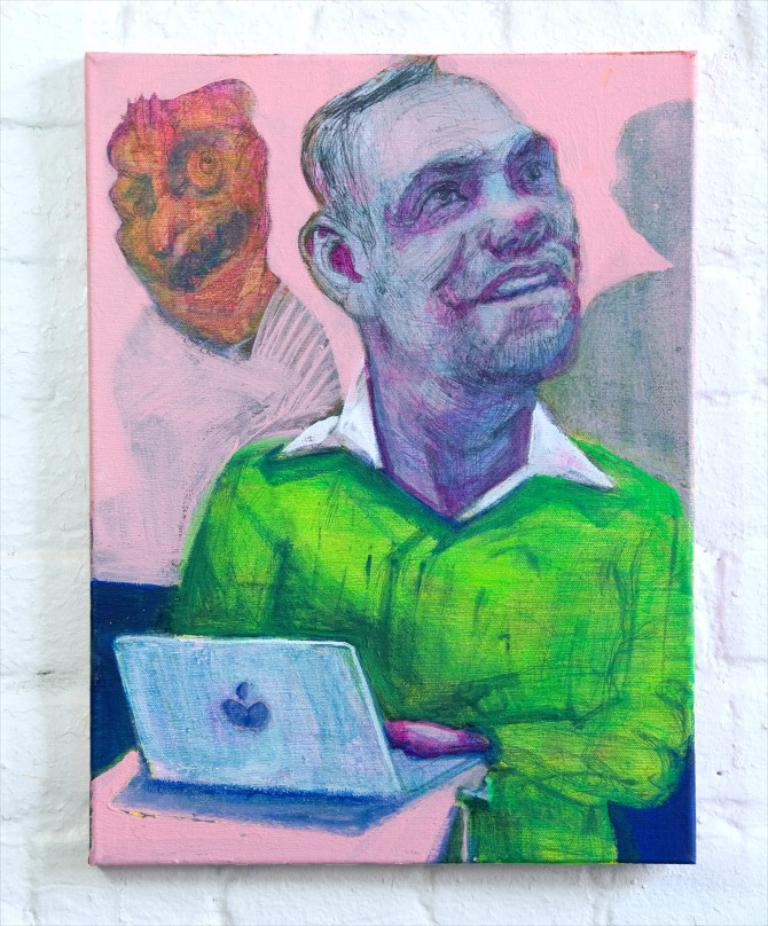What is the main subject of the painting in the image? The painting is of a man. Where is the painting located in the image? The painting is in the middle of the image. What is on the table in the image? A laptop is on the table. Where is the painting placed in the image? The painting is placed on a wall. What is the color of the wall in the image? The wall is white in color. What type of cloth is draped over the man in the painting? There is no cloth draped over the man in the painting; he is depicted without any clothing or accessories. 